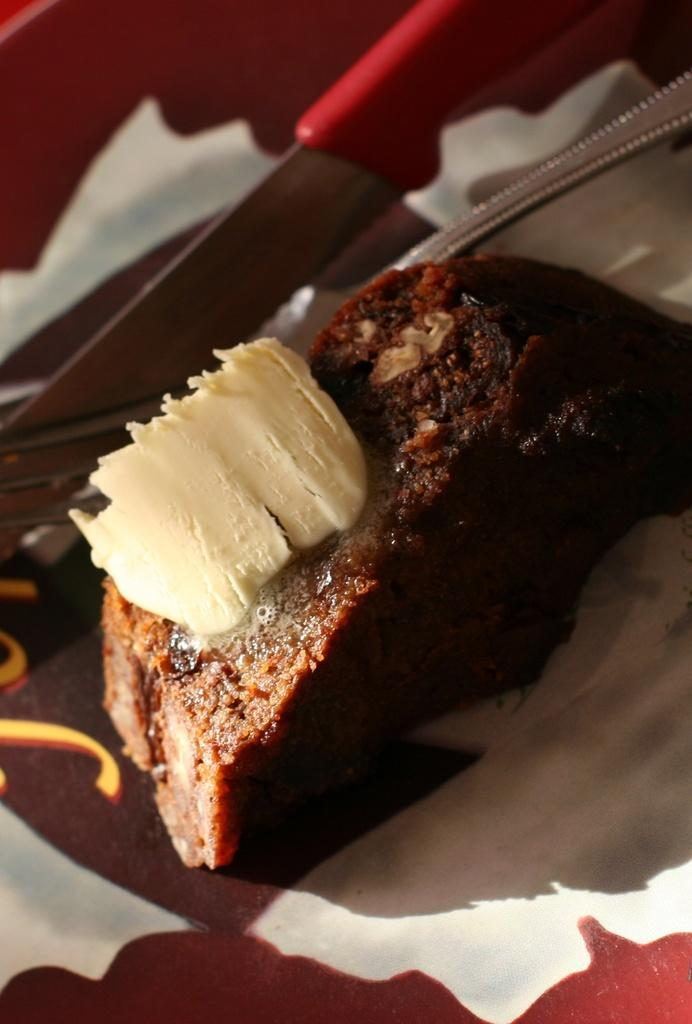What type of plate is visible in the image? There is a colorful plate in the image. What is on the plate? The plate contains a food item. Can you describe the appearance of the food item? The food item has brown, black, and cream colors. What utensils are present in the image? There is a knife and a fork in the image. What type of dress is the food item wearing in the image? The food item is not wearing a dress, as it is a food item and not a person or animate object. 